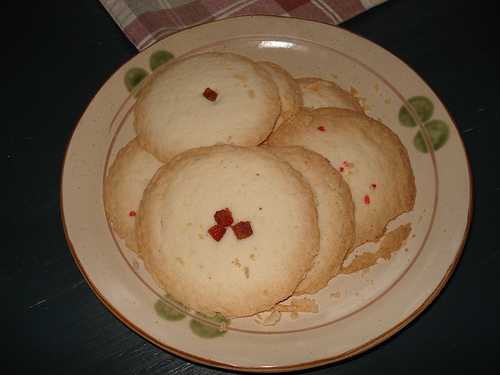<image>
Can you confirm if the cookies is on the plate? Yes. Looking at the image, I can see the cookies is positioned on top of the plate, with the plate providing support. Is there a plate to the right of the crumbs? No. The plate is not to the right of the crumbs. The horizontal positioning shows a different relationship. 